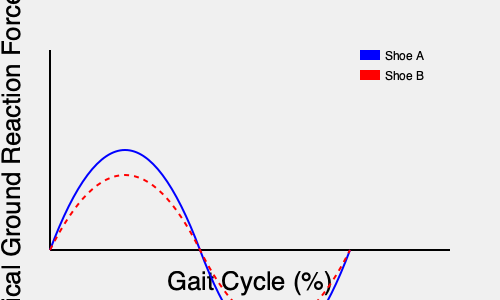Based on the graph showing vertical ground reaction force curves for two different shoe designs during a runner's gait cycle, which shoe design is likely to provide better shock absorption and potentially reduce the risk of impact-related injuries? To analyze the effect of different shoe designs on a runner's gait cycle and determine which design provides better shock absorption, we need to examine the vertical ground reaction force (vGRF) curves:

1. Observe the peak forces:
   - Shoe A (blue solid line) shows a higher peak force.
   - Shoe B (red dashed line) shows a lower peak force.

2. Analyze the loading rate:
   - Shoe A has a steeper initial slope, indicating a faster loading rate.
   - Shoe B has a more gradual initial slope, suggesting a slower loading rate.

3. Consider the impact on shock absorption:
   - Lower peak forces generally indicate better shock absorption.
   - Slower loading rates are associated with reduced impact stress.

4. Evaluate potential injury risk:
   - Higher peak forces and faster loading rates are often linked to increased risk of impact-related injuries.
   - Lower peak forces and slower loading rates typically reduce this risk.

5. Compare overall curve shapes:
   - Shoe B's curve is more rounded and distributed, suggesting better force distribution throughout the gait cycle.

Based on these observations, Shoe B (red dashed line) demonstrates characteristics associated with better shock absorption:
- Lower peak vGRF
- Slower initial loading rate
- More evenly distributed force curve

Therefore, Shoe B is likely to provide better shock absorption and potentially reduce the risk of impact-related injuries compared to Shoe A.
Answer: Shoe B 